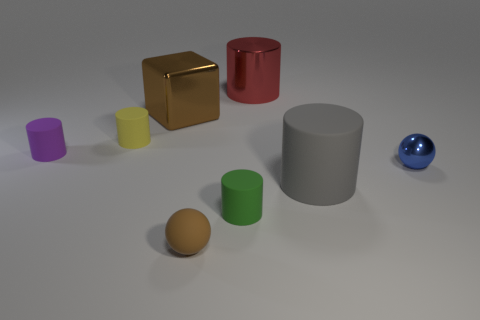Subtract all purple rubber cylinders. How many cylinders are left? 4 Add 2 tiny things. How many objects exist? 10 Subtract all green cylinders. How many cylinders are left? 4 Subtract all yellow cylinders. Subtract all gray balls. How many cylinders are left? 4 Add 8 yellow rubber cylinders. How many yellow rubber cylinders exist? 9 Subtract 0 green balls. How many objects are left? 8 Subtract all balls. How many objects are left? 6 Subtract all big brown cubes. Subtract all purple objects. How many objects are left? 6 Add 3 small green cylinders. How many small green cylinders are left? 4 